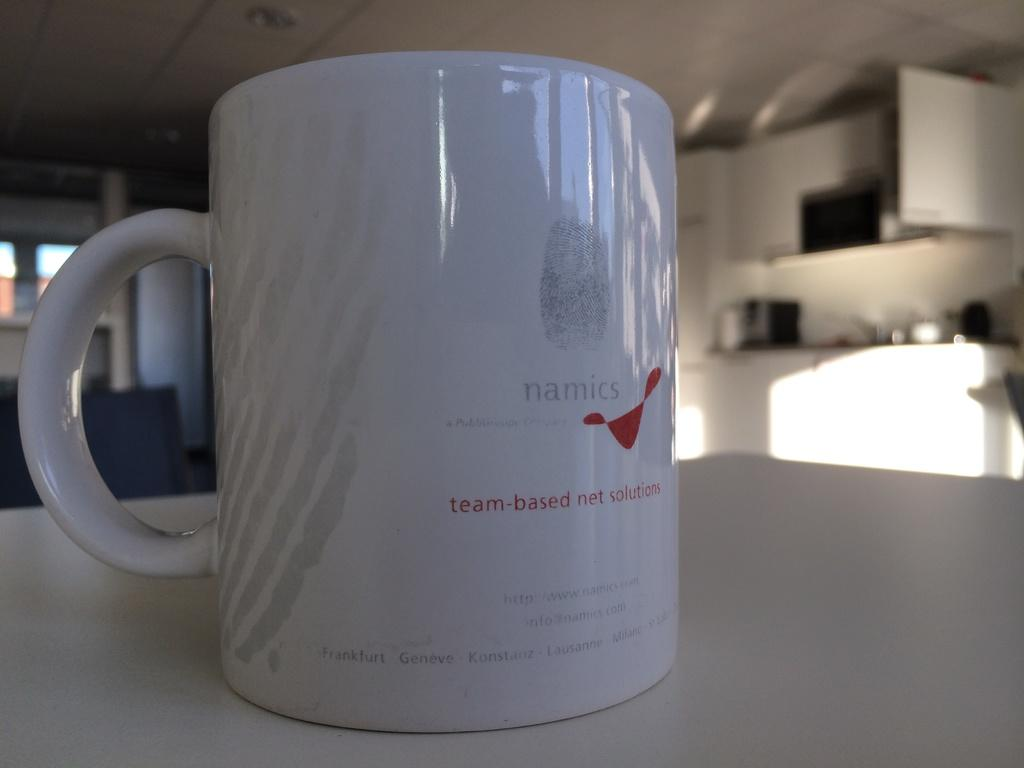What color is the cup in the image? The cup in the image is white. What is the cup placed on? The cup is on a white surface. What can be seen through the windows in the image? The windows in the image allow us to see the background. What is the color of the wall in the background? The wall in the background is white. What else can be seen in the background? There are objects visible in the background. What part of the room is visible above the cup? The ceiling is visible in the image. What is on the ceiling? There are lights on the ceiling. What type of stamp is on the underwear in the image? There is no underwear or stamp present in the image. 